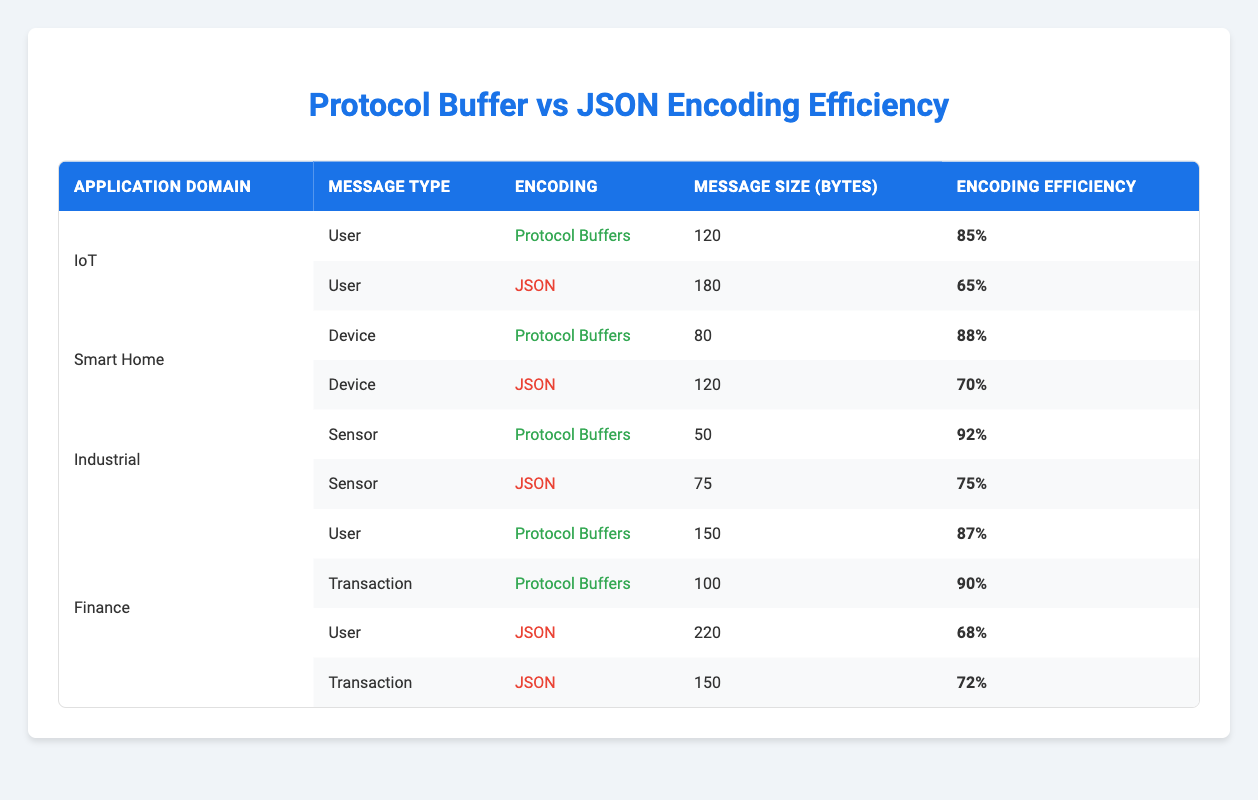What is the message size for the User type in the IoT application domain using Protocol Buffers? The table shows the IoT application domain and indicates that for the User message type using Protocol Buffers, the message size is 120 bytes.
Answer: 120 What is the encoding efficiency for Sensor messages using JSON in the Industrial domain? Looking in the Industrial application domain for the Sensor message type using JSON, the table specifies the encoding efficiency as 75%.
Answer: 75% Which encoding method has the highest encoding efficiency for the Device message type? For the Device message type in the Smart Home domain, the Protocol Buffers encoding has an efficiency of 88%, whereas JSON has a lower efficiency of 70%, making Protocol Buffers the highest.
Answer: Protocol Buffers What is the difference in message size between User messages in Finance using Protocol Buffers and JSON? The User message type for Finance shows a message size of 150 bytes for Protocol Buffers and 220 bytes for JSON. The difference is calculated as 220 - 150 = 70 bytes.
Answer: 70 In which application domain is the Protocol Buffers encoding efficiency the highest? Checking the encoding efficiencies for all application domains, Industrial shows the highest efficiency of 92% for Sensor messages using Protocol Buffers.
Answer: Industrial Are all Device messages encoded using Protocol Buffers smaller than their JSON counterparts? In the table, the Device message size using Protocol Buffers is 80 bytes, while the JSON encoding is 120 bytes. Therefore, the statement is true that all Device messages encoded using Protocol Buffers are smaller than their JSON counterparts.
Answer: Yes What is the average message size for all types using Protocol Buffers across the application domains? Adding up the message sizes: 120 (User) + 80 (Device) + 50 (Sensor) + 150 (User) + 100 (Transaction) = 500 bytes. There are 5 entries. The average is 500/5 = 100 bytes.
Answer: 100 How many application domains use JSON encoding for User message types? According to the data, there are two User message types encoded using JSON: one each in IoT and Finance domains. This means there are two application domains where User messages use JSON.
Answer: 2 What is the total encoding efficiency for all Transaction message types, both for Protocol Buffers and JSON? The efficiencies for Transaction messages are 90% for Protocol Buffers and 72% for JSON. Their total is 90 + 72 = 162%.
Answer: 162 